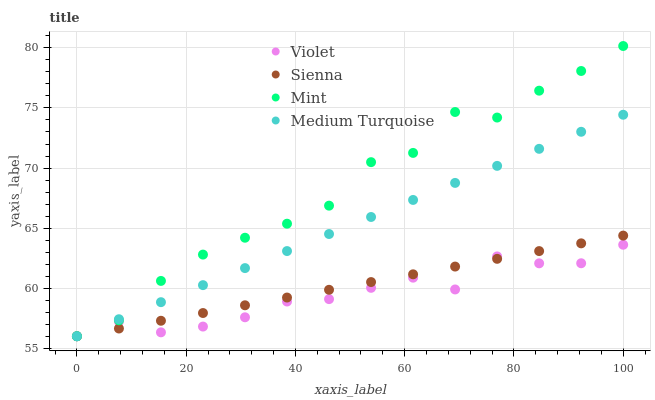Does Violet have the minimum area under the curve?
Answer yes or no. Yes. Does Mint have the maximum area under the curve?
Answer yes or no. Yes. Does Medium Turquoise have the minimum area under the curve?
Answer yes or no. No. Does Medium Turquoise have the maximum area under the curve?
Answer yes or no. No. Is Medium Turquoise the smoothest?
Answer yes or no. Yes. Is Mint the roughest?
Answer yes or no. Yes. Is Mint the smoothest?
Answer yes or no. No. Is Medium Turquoise the roughest?
Answer yes or no. No. Does Sienna have the lowest value?
Answer yes or no. Yes. Does Mint have the highest value?
Answer yes or no. Yes. Does Medium Turquoise have the highest value?
Answer yes or no. No. Does Violet intersect Medium Turquoise?
Answer yes or no. Yes. Is Violet less than Medium Turquoise?
Answer yes or no. No. Is Violet greater than Medium Turquoise?
Answer yes or no. No. 